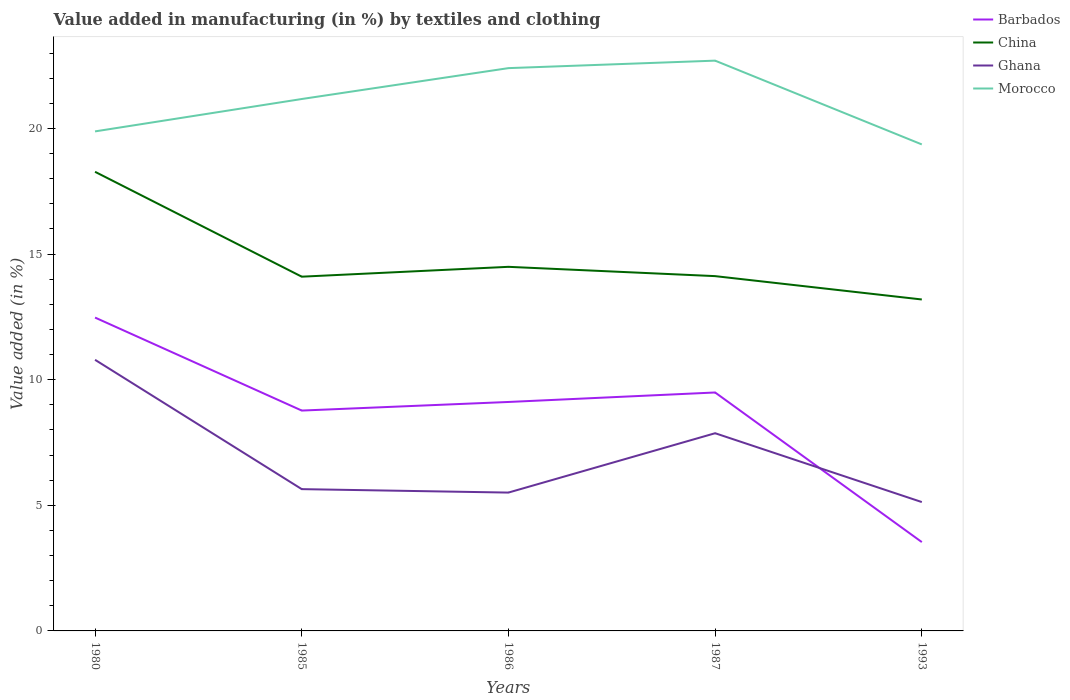How many different coloured lines are there?
Your answer should be compact. 4. Across all years, what is the maximum percentage of value added in manufacturing by textiles and clothing in Barbados?
Your answer should be very brief. 3.54. In which year was the percentage of value added in manufacturing by textiles and clothing in Morocco maximum?
Ensure brevity in your answer.  1993. What is the total percentage of value added in manufacturing by textiles and clothing in Morocco in the graph?
Give a very brief answer. -2.52. What is the difference between the highest and the second highest percentage of value added in manufacturing by textiles and clothing in Morocco?
Give a very brief answer. 3.33. What is the difference between the highest and the lowest percentage of value added in manufacturing by textiles and clothing in Ghana?
Make the answer very short. 2. How many lines are there?
Your response must be concise. 4. How many years are there in the graph?
Provide a succinct answer. 5. What is the difference between two consecutive major ticks on the Y-axis?
Your response must be concise. 5. Does the graph contain any zero values?
Keep it short and to the point. No. How are the legend labels stacked?
Offer a very short reply. Vertical. What is the title of the graph?
Your response must be concise. Value added in manufacturing (in %) by textiles and clothing. Does "Fragile and conflict affected situations" appear as one of the legend labels in the graph?
Ensure brevity in your answer.  No. What is the label or title of the X-axis?
Offer a terse response. Years. What is the label or title of the Y-axis?
Your response must be concise. Value added (in %). What is the Value added (in %) of Barbados in 1980?
Offer a very short reply. 12.47. What is the Value added (in %) of China in 1980?
Make the answer very short. 18.27. What is the Value added (in %) of Ghana in 1980?
Provide a succinct answer. 10.79. What is the Value added (in %) of Morocco in 1980?
Make the answer very short. 19.88. What is the Value added (in %) in Barbados in 1985?
Give a very brief answer. 8.77. What is the Value added (in %) in China in 1985?
Make the answer very short. 14.1. What is the Value added (in %) in Ghana in 1985?
Your response must be concise. 5.64. What is the Value added (in %) in Morocco in 1985?
Give a very brief answer. 21.17. What is the Value added (in %) in Barbados in 1986?
Your response must be concise. 9.11. What is the Value added (in %) in China in 1986?
Give a very brief answer. 14.49. What is the Value added (in %) in Ghana in 1986?
Give a very brief answer. 5.51. What is the Value added (in %) of Morocco in 1986?
Provide a short and direct response. 22.4. What is the Value added (in %) in Barbados in 1987?
Your answer should be very brief. 9.49. What is the Value added (in %) of China in 1987?
Offer a very short reply. 14.12. What is the Value added (in %) of Ghana in 1987?
Give a very brief answer. 7.87. What is the Value added (in %) in Morocco in 1987?
Provide a short and direct response. 22.7. What is the Value added (in %) in Barbados in 1993?
Ensure brevity in your answer.  3.54. What is the Value added (in %) of China in 1993?
Provide a succinct answer. 13.19. What is the Value added (in %) in Ghana in 1993?
Keep it short and to the point. 5.13. What is the Value added (in %) in Morocco in 1993?
Make the answer very short. 19.36. Across all years, what is the maximum Value added (in %) of Barbados?
Your answer should be compact. 12.47. Across all years, what is the maximum Value added (in %) in China?
Provide a succinct answer. 18.27. Across all years, what is the maximum Value added (in %) of Ghana?
Make the answer very short. 10.79. Across all years, what is the maximum Value added (in %) in Morocco?
Keep it short and to the point. 22.7. Across all years, what is the minimum Value added (in %) in Barbados?
Your answer should be compact. 3.54. Across all years, what is the minimum Value added (in %) of China?
Ensure brevity in your answer.  13.19. Across all years, what is the minimum Value added (in %) of Ghana?
Offer a very short reply. 5.13. Across all years, what is the minimum Value added (in %) in Morocco?
Your answer should be very brief. 19.36. What is the total Value added (in %) of Barbados in the graph?
Offer a very short reply. 43.38. What is the total Value added (in %) of China in the graph?
Keep it short and to the point. 74.18. What is the total Value added (in %) in Ghana in the graph?
Offer a terse response. 34.94. What is the total Value added (in %) in Morocco in the graph?
Offer a terse response. 105.51. What is the difference between the Value added (in %) in Barbados in 1980 and that in 1985?
Your response must be concise. 3.7. What is the difference between the Value added (in %) in China in 1980 and that in 1985?
Offer a very short reply. 4.17. What is the difference between the Value added (in %) of Ghana in 1980 and that in 1985?
Make the answer very short. 5.15. What is the difference between the Value added (in %) of Morocco in 1980 and that in 1985?
Give a very brief answer. -1.29. What is the difference between the Value added (in %) in Barbados in 1980 and that in 1986?
Offer a terse response. 3.36. What is the difference between the Value added (in %) of China in 1980 and that in 1986?
Give a very brief answer. 3.78. What is the difference between the Value added (in %) in Ghana in 1980 and that in 1986?
Ensure brevity in your answer.  5.28. What is the difference between the Value added (in %) in Morocco in 1980 and that in 1986?
Offer a terse response. -2.52. What is the difference between the Value added (in %) in Barbados in 1980 and that in 1987?
Give a very brief answer. 2.98. What is the difference between the Value added (in %) in China in 1980 and that in 1987?
Ensure brevity in your answer.  4.15. What is the difference between the Value added (in %) in Ghana in 1980 and that in 1987?
Keep it short and to the point. 2.92. What is the difference between the Value added (in %) of Morocco in 1980 and that in 1987?
Give a very brief answer. -2.82. What is the difference between the Value added (in %) in Barbados in 1980 and that in 1993?
Make the answer very short. 8.94. What is the difference between the Value added (in %) in China in 1980 and that in 1993?
Offer a terse response. 5.08. What is the difference between the Value added (in %) of Ghana in 1980 and that in 1993?
Your answer should be very brief. 5.66. What is the difference between the Value added (in %) of Morocco in 1980 and that in 1993?
Your answer should be compact. 0.52. What is the difference between the Value added (in %) in Barbados in 1985 and that in 1986?
Your answer should be very brief. -0.34. What is the difference between the Value added (in %) of China in 1985 and that in 1986?
Offer a very short reply. -0.39. What is the difference between the Value added (in %) in Ghana in 1985 and that in 1986?
Your response must be concise. 0.14. What is the difference between the Value added (in %) in Morocco in 1985 and that in 1986?
Your response must be concise. -1.23. What is the difference between the Value added (in %) of Barbados in 1985 and that in 1987?
Offer a terse response. -0.72. What is the difference between the Value added (in %) of China in 1985 and that in 1987?
Provide a succinct answer. -0.02. What is the difference between the Value added (in %) in Ghana in 1985 and that in 1987?
Provide a short and direct response. -2.23. What is the difference between the Value added (in %) in Morocco in 1985 and that in 1987?
Keep it short and to the point. -1.53. What is the difference between the Value added (in %) of Barbados in 1985 and that in 1993?
Offer a terse response. 5.24. What is the difference between the Value added (in %) of China in 1985 and that in 1993?
Give a very brief answer. 0.91. What is the difference between the Value added (in %) of Ghana in 1985 and that in 1993?
Provide a short and direct response. 0.51. What is the difference between the Value added (in %) in Morocco in 1985 and that in 1993?
Ensure brevity in your answer.  1.81. What is the difference between the Value added (in %) in Barbados in 1986 and that in 1987?
Your answer should be very brief. -0.38. What is the difference between the Value added (in %) in China in 1986 and that in 1987?
Your response must be concise. 0.37. What is the difference between the Value added (in %) in Ghana in 1986 and that in 1987?
Your response must be concise. -2.36. What is the difference between the Value added (in %) in Morocco in 1986 and that in 1987?
Your answer should be compact. -0.3. What is the difference between the Value added (in %) of Barbados in 1986 and that in 1993?
Ensure brevity in your answer.  5.58. What is the difference between the Value added (in %) of China in 1986 and that in 1993?
Ensure brevity in your answer.  1.3. What is the difference between the Value added (in %) of Ghana in 1986 and that in 1993?
Your answer should be compact. 0.38. What is the difference between the Value added (in %) in Morocco in 1986 and that in 1993?
Keep it short and to the point. 3.04. What is the difference between the Value added (in %) in Barbados in 1987 and that in 1993?
Give a very brief answer. 5.95. What is the difference between the Value added (in %) in China in 1987 and that in 1993?
Provide a succinct answer. 0.93. What is the difference between the Value added (in %) in Ghana in 1987 and that in 1993?
Your answer should be very brief. 2.74. What is the difference between the Value added (in %) in Morocco in 1987 and that in 1993?
Ensure brevity in your answer.  3.33. What is the difference between the Value added (in %) of Barbados in 1980 and the Value added (in %) of China in 1985?
Ensure brevity in your answer.  -1.63. What is the difference between the Value added (in %) of Barbados in 1980 and the Value added (in %) of Ghana in 1985?
Provide a succinct answer. 6.83. What is the difference between the Value added (in %) in Barbados in 1980 and the Value added (in %) in Morocco in 1985?
Provide a short and direct response. -8.7. What is the difference between the Value added (in %) in China in 1980 and the Value added (in %) in Ghana in 1985?
Your answer should be very brief. 12.63. What is the difference between the Value added (in %) of China in 1980 and the Value added (in %) of Morocco in 1985?
Make the answer very short. -2.9. What is the difference between the Value added (in %) of Ghana in 1980 and the Value added (in %) of Morocco in 1985?
Make the answer very short. -10.38. What is the difference between the Value added (in %) of Barbados in 1980 and the Value added (in %) of China in 1986?
Provide a succinct answer. -2.02. What is the difference between the Value added (in %) of Barbados in 1980 and the Value added (in %) of Ghana in 1986?
Offer a very short reply. 6.97. What is the difference between the Value added (in %) in Barbados in 1980 and the Value added (in %) in Morocco in 1986?
Your answer should be very brief. -9.93. What is the difference between the Value added (in %) of China in 1980 and the Value added (in %) of Ghana in 1986?
Provide a short and direct response. 12.77. What is the difference between the Value added (in %) in China in 1980 and the Value added (in %) in Morocco in 1986?
Provide a succinct answer. -4.13. What is the difference between the Value added (in %) in Ghana in 1980 and the Value added (in %) in Morocco in 1986?
Provide a succinct answer. -11.61. What is the difference between the Value added (in %) of Barbados in 1980 and the Value added (in %) of China in 1987?
Offer a terse response. -1.65. What is the difference between the Value added (in %) in Barbados in 1980 and the Value added (in %) in Ghana in 1987?
Offer a terse response. 4.6. What is the difference between the Value added (in %) of Barbados in 1980 and the Value added (in %) of Morocco in 1987?
Your answer should be compact. -10.23. What is the difference between the Value added (in %) of China in 1980 and the Value added (in %) of Ghana in 1987?
Provide a succinct answer. 10.4. What is the difference between the Value added (in %) in China in 1980 and the Value added (in %) in Morocco in 1987?
Make the answer very short. -4.42. What is the difference between the Value added (in %) of Ghana in 1980 and the Value added (in %) of Morocco in 1987?
Ensure brevity in your answer.  -11.91. What is the difference between the Value added (in %) of Barbados in 1980 and the Value added (in %) of China in 1993?
Provide a short and direct response. -0.72. What is the difference between the Value added (in %) in Barbados in 1980 and the Value added (in %) in Ghana in 1993?
Offer a terse response. 7.34. What is the difference between the Value added (in %) of Barbados in 1980 and the Value added (in %) of Morocco in 1993?
Provide a succinct answer. -6.89. What is the difference between the Value added (in %) in China in 1980 and the Value added (in %) in Ghana in 1993?
Provide a succinct answer. 13.14. What is the difference between the Value added (in %) in China in 1980 and the Value added (in %) in Morocco in 1993?
Offer a very short reply. -1.09. What is the difference between the Value added (in %) in Ghana in 1980 and the Value added (in %) in Morocco in 1993?
Offer a terse response. -8.57. What is the difference between the Value added (in %) of Barbados in 1985 and the Value added (in %) of China in 1986?
Provide a succinct answer. -5.72. What is the difference between the Value added (in %) in Barbados in 1985 and the Value added (in %) in Ghana in 1986?
Provide a succinct answer. 3.26. What is the difference between the Value added (in %) in Barbados in 1985 and the Value added (in %) in Morocco in 1986?
Provide a short and direct response. -13.63. What is the difference between the Value added (in %) in China in 1985 and the Value added (in %) in Ghana in 1986?
Your answer should be compact. 8.59. What is the difference between the Value added (in %) of China in 1985 and the Value added (in %) of Morocco in 1986?
Keep it short and to the point. -8.3. What is the difference between the Value added (in %) in Ghana in 1985 and the Value added (in %) in Morocco in 1986?
Provide a succinct answer. -16.76. What is the difference between the Value added (in %) of Barbados in 1985 and the Value added (in %) of China in 1987?
Make the answer very short. -5.35. What is the difference between the Value added (in %) in Barbados in 1985 and the Value added (in %) in Ghana in 1987?
Provide a short and direct response. 0.9. What is the difference between the Value added (in %) of Barbados in 1985 and the Value added (in %) of Morocco in 1987?
Give a very brief answer. -13.93. What is the difference between the Value added (in %) in China in 1985 and the Value added (in %) in Ghana in 1987?
Your response must be concise. 6.23. What is the difference between the Value added (in %) of China in 1985 and the Value added (in %) of Morocco in 1987?
Provide a succinct answer. -8.6. What is the difference between the Value added (in %) of Ghana in 1985 and the Value added (in %) of Morocco in 1987?
Give a very brief answer. -17.05. What is the difference between the Value added (in %) of Barbados in 1985 and the Value added (in %) of China in 1993?
Provide a short and direct response. -4.42. What is the difference between the Value added (in %) in Barbados in 1985 and the Value added (in %) in Ghana in 1993?
Give a very brief answer. 3.64. What is the difference between the Value added (in %) of Barbados in 1985 and the Value added (in %) of Morocco in 1993?
Keep it short and to the point. -10.59. What is the difference between the Value added (in %) in China in 1985 and the Value added (in %) in Ghana in 1993?
Your response must be concise. 8.97. What is the difference between the Value added (in %) in China in 1985 and the Value added (in %) in Morocco in 1993?
Ensure brevity in your answer.  -5.26. What is the difference between the Value added (in %) in Ghana in 1985 and the Value added (in %) in Morocco in 1993?
Provide a succinct answer. -13.72. What is the difference between the Value added (in %) of Barbados in 1986 and the Value added (in %) of China in 1987?
Keep it short and to the point. -5.01. What is the difference between the Value added (in %) in Barbados in 1986 and the Value added (in %) in Ghana in 1987?
Keep it short and to the point. 1.24. What is the difference between the Value added (in %) in Barbados in 1986 and the Value added (in %) in Morocco in 1987?
Your answer should be very brief. -13.58. What is the difference between the Value added (in %) of China in 1986 and the Value added (in %) of Ghana in 1987?
Provide a succinct answer. 6.62. What is the difference between the Value added (in %) of China in 1986 and the Value added (in %) of Morocco in 1987?
Provide a short and direct response. -8.21. What is the difference between the Value added (in %) in Ghana in 1986 and the Value added (in %) in Morocco in 1987?
Ensure brevity in your answer.  -17.19. What is the difference between the Value added (in %) of Barbados in 1986 and the Value added (in %) of China in 1993?
Provide a succinct answer. -4.08. What is the difference between the Value added (in %) in Barbados in 1986 and the Value added (in %) in Ghana in 1993?
Your answer should be very brief. 3.98. What is the difference between the Value added (in %) of Barbados in 1986 and the Value added (in %) of Morocco in 1993?
Your response must be concise. -10.25. What is the difference between the Value added (in %) in China in 1986 and the Value added (in %) in Ghana in 1993?
Your answer should be very brief. 9.36. What is the difference between the Value added (in %) of China in 1986 and the Value added (in %) of Morocco in 1993?
Keep it short and to the point. -4.87. What is the difference between the Value added (in %) in Ghana in 1986 and the Value added (in %) in Morocco in 1993?
Provide a short and direct response. -13.86. What is the difference between the Value added (in %) of Barbados in 1987 and the Value added (in %) of China in 1993?
Offer a terse response. -3.7. What is the difference between the Value added (in %) of Barbados in 1987 and the Value added (in %) of Ghana in 1993?
Your answer should be compact. 4.36. What is the difference between the Value added (in %) of Barbados in 1987 and the Value added (in %) of Morocco in 1993?
Give a very brief answer. -9.87. What is the difference between the Value added (in %) in China in 1987 and the Value added (in %) in Ghana in 1993?
Offer a terse response. 8.99. What is the difference between the Value added (in %) in China in 1987 and the Value added (in %) in Morocco in 1993?
Your answer should be compact. -5.24. What is the difference between the Value added (in %) of Ghana in 1987 and the Value added (in %) of Morocco in 1993?
Provide a short and direct response. -11.49. What is the average Value added (in %) in Barbados per year?
Offer a very short reply. 8.68. What is the average Value added (in %) of China per year?
Your answer should be compact. 14.84. What is the average Value added (in %) in Ghana per year?
Keep it short and to the point. 6.99. What is the average Value added (in %) of Morocco per year?
Ensure brevity in your answer.  21.1. In the year 1980, what is the difference between the Value added (in %) of Barbados and Value added (in %) of China?
Provide a short and direct response. -5.8. In the year 1980, what is the difference between the Value added (in %) in Barbados and Value added (in %) in Ghana?
Ensure brevity in your answer.  1.68. In the year 1980, what is the difference between the Value added (in %) of Barbados and Value added (in %) of Morocco?
Provide a succinct answer. -7.41. In the year 1980, what is the difference between the Value added (in %) in China and Value added (in %) in Ghana?
Make the answer very short. 7.48. In the year 1980, what is the difference between the Value added (in %) in China and Value added (in %) in Morocco?
Keep it short and to the point. -1.61. In the year 1980, what is the difference between the Value added (in %) of Ghana and Value added (in %) of Morocco?
Your answer should be compact. -9.09. In the year 1985, what is the difference between the Value added (in %) in Barbados and Value added (in %) in China?
Keep it short and to the point. -5.33. In the year 1985, what is the difference between the Value added (in %) in Barbados and Value added (in %) in Ghana?
Make the answer very short. 3.13. In the year 1985, what is the difference between the Value added (in %) in China and Value added (in %) in Ghana?
Make the answer very short. 8.46. In the year 1985, what is the difference between the Value added (in %) in China and Value added (in %) in Morocco?
Your response must be concise. -7.07. In the year 1985, what is the difference between the Value added (in %) in Ghana and Value added (in %) in Morocco?
Your answer should be compact. -15.53. In the year 1986, what is the difference between the Value added (in %) of Barbados and Value added (in %) of China?
Give a very brief answer. -5.38. In the year 1986, what is the difference between the Value added (in %) of Barbados and Value added (in %) of Ghana?
Ensure brevity in your answer.  3.61. In the year 1986, what is the difference between the Value added (in %) of Barbados and Value added (in %) of Morocco?
Make the answer very short. -13.29. In the year 1986, what is the difference between the Value added (in %) of China and Value added (in %) of Ghana?
Your response must be concise. 8.99. In the year 1986, what is the difference between the Value added (in %) of China and Value added (in %) of Morocco?
Ensure brevity in your answer.  -7.91. In the year 1986, what is the difference between the Value added (in %) in Ghana and Value added (in %) in Morocco?
Give a very brief answer. -16.89. In the year 1987, what is the difference between the Value added (in %) of Barbados and Value added (in %) of China?
Keep it short and to the point. -4.63. In the year 1987, what is the difference between the Value added (in %) of Barbados and Value added (in %) of Ghana?
Give a very brief answer. 1.62. In the year 1987, what is the difference between the Value added (in %) of Barbados and Value added (in %) of Morocco?
Give a very brief answer. -13.21. In the year 1987, what is the difference between the Value added (in %) in China and Value added (in %) in Ghana?
Your answer should be very brief. 6.25. In the year 1987, what is the difference between the Value added (in %) of China and Value added (in %) of Morocco?
Offer a terse response. -8.58. In the year 1987, what is the difference between the Value added (in %) of Ghana and Value added (in %) of Morocco?
Your answer should be very brief. -14.83. In the year 1993, what is the difference between the Value added (in %) in Barbados and Value added (in %) in China?
Offer a very short reply. -9.66. In the year 1993, what is the difference between the Value added (in %) in Barbados and Value added (in %) in Ghana?
Give a very brief answer. -1.59. In the year 1993, what is the difference between the Value added (in %) of Barbados and Value added (in %) of Morocco?
Provide a short and direct response. -15.83. In the year 1993, what is the difference between the Value added (in %) in China and Value added (in %) in Ghana?
Ensure brevity in your answer.  8.06. In the year 1993, what is the difference between the Value added (in %) in China and Value added (in %) in Morocco?
Your answer should be very brief. -6.17. In the year 1993, what is the difference between the Value added (in %) of Ghana and Value added (in %) of Morocco?
Offer a very short reply. -14.23. What is the ratio of the Value added (in %) in Barbados in 1980 to that in 1985?
Your answer should be compact. 1.42. What is the ratio of the Value added (in %) of China in 1980 to that in 1985?
Your answer should be very brief. 1.3. What is the ratio of the Value added (in %) of Ghana in 1980 to that in 1985?
Your response must be concise. 1.91. What is the ratio of the Value added (in %) in Morocco in 1980 to that in 1985?
Offer a very short reply. 0.94. What is the ratio of the Value added (in %) in Barbados in 1980 to that in 1986?
Provide a short and direct response. 1.37. What is the ratio of the Value added (in %) in China in 1980 to that in 1986?
Give a very brief answer. 1.26. What is the ratio of the Value added (in %) of Ghana in 1980 to that in 1986?
Give a very brief answer. 1.96. What is the ratio of the Value added (in %) of Morocco in 1980 to that in 1986?
Provide a short and direct response. 0.89. What is the ratio of the Value added (in %) of Barbados in 1980 to that in 1987?
Make the answer very short. 1.31. What is the ratio of the Value added (in %) in China in 1980 to that in 1987?
Your answer should be compact. 1.29. What is the ratio of the Value added (in %) in Ghana in 1980 to that in 1987?
Make the answer very short. 1.37. What is the ratio of the Value added (in %) of Morocco in 1980 to that in 1987?
Provide a short and direct response. 0.88. What is the ratio of the Value added (in %) in Barbados in 1980 to that in 1993?
Keep it short and to the point. 3.53. What is the ratio of the Value added (in %) in China in 1980 to that in 1993?
Provide a succinct answer. 1.39. What is the ratio of the Value added (in %) in Ghana in 1980 to that in 1993?
Your response must be concise. 2.1. What is the ratio of the Value added (in %) of Morocco in 1980 to that in 1993?
Make the answer very short. 1.03. What is the ratio of the Value added (in %) of Barbados in 1985 to that in 1986?
Your response must be concise. 0.96. What is the ratio of the Value added (in %) in China in 1985 to that in 1986?
Offer a very short reply. 0.97. What is the ratio of the Value added (in %) in Ghana in 1985 to that in 1986?
Provide a succinct answer. 1.02. What is the ratio of the Value added (in %) in Morocco in 1985 to that in 1986?
Your response must be concise. 0.95. What is the ratio of the Value added (in %) in Barbados in 1985 to that in 1987?
Your response must be concise. 0.92. What is the ratio of the Value added (in %) of Ghana in 1985 to that in 1987?
Your answer should be very brief. 0.72. What is the ratio of the Value added (in %) of Morocco in 1985 to that in 1987?
Ensure brevity in your answer.  0.93. What is the ratio of the Value added (in %) in Barbados in 1985 to that in 1993?
Offer a terse response. 2.48. What is the ratio of the Value added (in %) in China in 1985 to that in 1993?
Your answer should be very brief. 1.07. What is the ratio of the Value added (in %) in Ghana in 1985 to that in 1993?
Give a very brief answer. 1.1. What is the ratio of the Value added (in %) in Morocco in 1985 to that in 1993?
Your response must be concise. 1.09. What is the ratio of the Value added (in %) of Barbados in 1986 to that in 1987?
Make the answer very short. 0.96. What is the ratio of the Value added (in %) of China in 1986 to that in 1987?
Ensure brevity in your answer.  1.03. What is the ratio of the Value added (in %) of Ghana in 1986 to that in 1987?
Your answer should be very brief. 0.7. What is the ratio of the Value added (in %) in Morocco in 1986 to that in 1987?
Your answer should be very brief. 0.99. What is the ratio of the Value added (in %) in Barbados in 1986 to that in 1993?
Your response must be concise. 2.58. What is the ratio of the Value added (in %) of China in 1986 to that in 1993?
Ensure brevity in your answer.  1.1. What is the ratio of the Value added (in %) in Ghana in 1986 to that in 1993?
Provide a short and direct response. 1.07. What is the ratio of the Value added (in %) in Morocco in 1986 to that in 1993?
Provide a short and direct response. 1.16. What is the ratio of the Value added (in %) of Barbados in 1987 to that in 1993?
Offer a terse response. 2.68. What is the ratio of the Value added (in %) of China in 1987 to that in 1993?
Keep it short and to the point. 1.07. What is the ratio of the Value added (in %) of Ghana in 1987 to that in 1993?
Your answer should be compact. 1.53. What is the ratio of the Value added (in %) in Morocco in 1987 to that in 1993?
Offer a very short reply. 1.17. What is the difference between the highest and the second highest Value added (in %) of Barbados?
Offer a very short reply. 2.98. What is the difference between the highest and the second highest Value added (in %) of China?
Offer a terse response. 3.78. What is the difference between the highest and the second highest Value added (in %) in Ghana?
Offer a very short reply. 2.92. What is the difference between the highest and the second highest Value added (in %) of Morocco?
Provide a short and direct response. 0.3. What is the difference between the highest and the lowest Value added (in %) of Barbados?
Offer a very short reply. 8.94. What is the difference between the highest and the lowest Value added (in %) of China?
Ensure brevity in your answer.  5.08. What is the difference between the highest and the lowest Value added (in %) of Ghana?
Provide a succinct answer. 5.66. What is the difference between the highest and the lowest Value added (in %) of Morocco?
Your response must be concise. 3.33. 